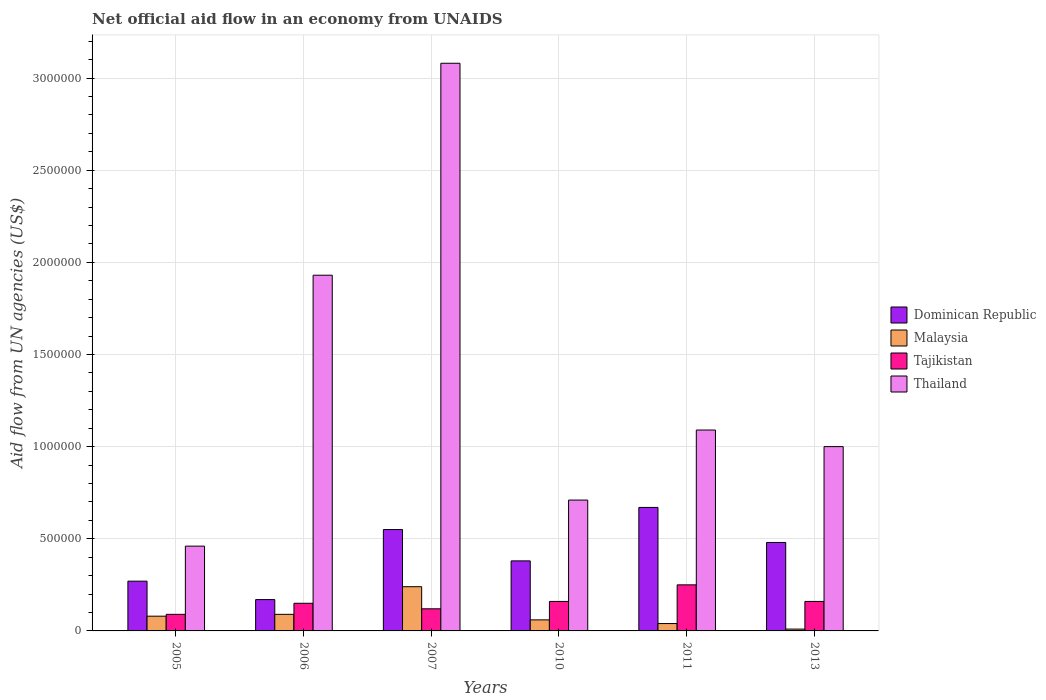How many different coloured bars are there?
Ensure brevity in your answer.  4. How many bars are there on the 1st tick from the left?
Make the answer very short. 4. How many bars are there on the 6th tick from the right?
Provide a succinct answer. 4. In how many cases, is the number of bars for a given year not equal to the number of legend labels?
Your answer should be compact. 0. What is the net official aid flow in Thailand in 2010?
Your answer should be compact. 7.10e+05. In which year was the net official aid flow in Tajikistan maximum?
Offer a terse response. 2011. In which year was the net official aid flow in Dominican Republic minimum?
Your answer should be compact. 2006. What is the total net official aid flow in Dominican Republic in the graph?
Your answer should be compact. 2.52e+06. What is the difference between the net official aid flow in Thailand in 2006 and that in 2010?
Make the answer very short. 1.22e+06. What is the difference between the net official aid flow in Thailand in 2005 and the net official aid flow in Malaysia in 2006?
Your answer should be compact. 3.70e+05. What is the average net official aid flow in Dominican Republic per year?
Ensure brevity in your answer.  4.20e+05. In the year 2011, what is the difference between the net official aid flow in Malaysia and net official aid flow in Dominican Republic?
Give a very brief answer. -6.30e+05. What is the ratio of the net official aid flow in Malaysia in 2006 to that in 2013?
Your answer should be very brief. 9. Is the net official aid flow in Thailand in 2007 less than that in 2010?
Your answer should be very brief. No. What is the difference between the highest and the second highest net official aid flow in Malaysia?
Keep it short and to the point. 1.50e+05. What is the difference between the highest and the lowest net official aid flow in Tajikistan?
Provide a succinct answer. 1.60e+05. What does the 2nd bar from the left in 2006 represents?
Your response must be concise. Malaysia. What does the 2nd bar from the right in 2005 represents?
Ensure brevity in your answer.  Tajikistan. Is it the case that in every year, the sum of the net official aid flow in Dominican Republic and net official aid flow in Thailand is greater than the net official aid flow in Malaysia?
Your answer should be very brief. Yes. How many years are there in the graph?
Make the answer very short. 6. Are the values on the major ticks of Y-axis written in scientific E-notation?
Offer a terse response. No. Does the graph contain grids?
Keep it short and to the point. Yes. What is the title of the graph?
Provide a succinct answer. Net official aid flow in an economy from UNAIDS. Does "Lao PDR" appear as one of the legend labels in the graph?
Keep it short and to the point. No. What is the label or title of the X-axis?
Give a very brief answer. Years. What is the label or title of the Y-axis?
Your answer should be compact. Aid flow from UN agencies (US$). What is the Aid flow from UN agencies (US$) in Malaysia in 2005?
Give a very brief answer. 8.00e+04. What is the Aid flow from UN agencies (US$) of Thailand in 2005?
Your answer should be very brief. 4.60e+05. What is the Aid flow from UN agencies (US$) of Dominican Republic in 2006?
Provide a succinct answer. 1.70e+05. What is the Aid flow from UN agencies (US$) of Malaysia in 2006?
Give a very brief answer. 9.00e+04. What is the Aid flow from UN agencies (US$) of Thailand in 2006?
Provide a short and direct response. 1.93e+06. What is the Aid flow from UN agencies (US$) of Dominican Republic in 2007?
Keep it short and to the point. 5.50e+05. What is the Aid flow from UN agencies (US$) of Tajikistan in 2007?
Ensure brevity in your answer.  1.20e+05. What is the Aid flow from UN agencies (US$) of Thailand in 2007?
Your answer should be compact. 3.08e+06. What is the Aid flow from UN agencies (US$) in Dominican Republic in 2010?
Your answer should be very brief. 3.80e+05. What is the Aid flow from UN agencies (US$) in Tajikistan in 2010?
Provide a succinct answer. 1.60e+05. What is the Aid flow from UN agencies (US$) of Thailand in 2010?
Offer a terse response. 7.10e+05. What is the Aid flow from UN agencies (US$) of Dominican Republic in 2011?
Your response must be concise. 6.70e+05. What is the Aid flow from UN agencies (US$) of Tajikistan in 2011?
Ensure brevity in your answer.  2.50e+05. What is the Aid flow from UN agencies (US$) in Thailand in 2011?
Provide a succinct answer. 1.09e+06. What is the Aid flow from UN agencies (US$) of Malaysia in 2013?
Ensure brevity in your answer.  10000. Across all years, what is the maximum Aid flow from UN agencies (US$) in Dominican Republic?
Ensure brevity in your answer.  6.70e+05. Across all years, what is the maximum Aid flow from UN agencies (US$) in Tajikistan?
Provide a succinct answer. 2.50e+05. Across all years, what is the maximum Aid flow from UN agencies (US$) of Thailand?
Your answer should be very brief. 3.08e+06. Across all years, what is the minimum Aid flow from UN agencies (US$) in Malaysia?
Offer a very short reply. 10000. Across all years, what is the minimum Aid flow from UN agencies (US$) in Tajikistan?
Keep it short and to the point. 9.00e+04. Across all years, what is the minimum Aid flow from UN agencies (US$) of Thailand?
Offer a terse response. 4.60e+05. What is the total Aid flow from UN agencies (US$) in Dominican Republic in the graph?
Provide a succinct answer. 2.52e+06. What is the total Aid flow from UN agencies (US$) in Malaysia in the graph?
Keep it short and to the point. 5.20e+05. What is the total Aid flow from UN agencies (US$) of Tajikistan in the graph?
Offer a terse response. 9.30e+05. What is the total Aid flow from UN agencies (US$) of Thailand in the graph?
Ensure brevity in your answer.  8.27e+06. What is the difference between the Aid flow from UN agencies (US$) in Malaysia in 2005 and that in 2006?
Make the answer very short. -10000. What is the difference between the Aid flow from UN agencies (US$) in Tajikistan in 2005 and that in 2006?
Offer a very short reply. -6.00e+04. What is the difference between the Aid flow from UN agencies (US$) in Thailand in 2005 and that in 2006?
Provide a short and direct response. -1.47e+06. What is the difference between the Aid flow from UN agencies (US$) of Dominican Republic in 2005 and that in 2007?
Provide a succinct answer. -2.80e+05. What is the difference between the Aid flow from UN agencies (US$) in Tajikistan in 2005 and that in 2007?
Provide a succinct answer. -3.00e+04. What is the difference between the Aid flow from UN agencies (US$) of Thailand in 2005 and that in 2007?
Offer a very short reply. -2.62e+06. What is the difference between the Aid flow from UN agencies (US$) in Dominican Republic in 2005 and that in 2011?
Offer a very short reply. -4.00e+05. What is the difference between the Aid flow from UN agencies (US$) in Malaysia in 2005 and that in 2011?
Offer a very short reply. 4.00e+04. What is the difference between the Aid flow from UN agencies (US$) of Tajikistan in 2005 and that in 2011?
Give a very brief answer. -1.60e+05. What is the difference between the Aid flow from UN agencies (US$) in Thailand in 2005 and that in 2011?
Offer a very short reply. -6.30e+05. What is the difference between the Aid flow from UN agencies (US$) in Malaysia in 2005 and that in 2013?
Your answer should be compact. 7.00e+04. What is the difference between the Aid flow from UN agencies (US$) of Tajikistan in 2005 and that in 2013?
Your answer should be very brief. -7.00e+04. What is the difference between the Aid flow from UN agencies (US$) in Thailand in 2005 and that in 2013?
Your answer should be compact. -5.40e+05. What is the difference between the Aid flow from UN agencies (US$) of Dominican Republic in 2006 and that in 2007?
Make the answer very short. -3.80e+05. What is the difference between the Aid flow from UN agencies (US$) of Thailand in 2006 and that in 2007?
Your answer should be very brief. -1.15e+06. What is the difference between the Aid flow from UN agencies (US$) of Dominican Republic in 2006 and that in 2010?
Your answer should be compact. -2.10e+05. What is the difference between the Aid flow from UN agencies (US$) in Tajikistan in 2006 and that in 2010?
Make the answer very short. -10000. What is the difference between the Aid flow from UN agencies (US$) in Thailand in 2006 and that in 2010?
Ensure brevity in your answer.  1.22e+06. What is the difference between the Aid flow from UN agencies (US$) of Dominican Republic in 2006 and that in 2011?
Keep it short and to the point. -5.00e+05. What is the difference between the Aid flow from UN agencies (US$) of Tajikistan in 2006 and that in 2011?
Your answer should be compact. -1.00e+05. What is the difference between the Aid flow from UN agencies (US$) in Thailand in 2006 and that in 2011?
Make the answer very short. 8.40e+05. What is the difference between the Aid flow from UN agencies (US$) in Dominican Republic in 2006 and that in 2013?
Offer a terse response. -3.10e+05. What is the difference between the Aid flow from UN agencies (US$) in Tajikistan in 2006 and that in 2013?
Your answer should be compact. -10000. What is the difference between the Aid flow from UN agencies (US$) in Thailand in 2006 and that in 2013?
Your answer should be compact. 9.30e+05. What is the difference between the Aid flow from UN agencies (US$) of Dominican Republic in 2007 and that in 2010?
Your response must be concise. 1.70e+05. What is the difference between the Aid flow from UN agencies (US$) in Malaysia in 2007 and that in 2010?
Ensure brevity in your answer.  1.80e+05. What is the difference between the Aid flow from UN agencies (US$) in Tajikistan in 2007 and that in 2010?
Your answer should be compact. -4.00e+04. What is the difference between the Aid flow from UN agencies (US$) of Thailand in 2007 and that in 2010?
Your answer should be compact. 2.37e+06. What is the difference between the Aid flow from UN agencies (US$) of Malaysia in 2007 and that in 2011?
Provide a succinct answer. 2.00e+05. What is the difference between the Aid flow from UN agencies (US$) in Thailand in 2007 and that in 2011?
Keep it short and to the point. 1.99e+06. What is the difference between the Aid flow from UN agencies (US$) in Dominican Republic in 2007 and that in 2013?
Your answer should be very brief. 7.00e+04. What is the difference between the Aid flow from UN agencies (US$) in Thailand in 2007 and that in 2013?
Provide a succinct answer. 2.08e+06. What is the difference between the Aid flow from UN agencies (US$) in Dominican Republic in 2010 and that in 2011?
Ensure brevity in your answer.  -2.90e+05. What is the difference between the Aid flow from UN agencies (US$) of Thailand in 2010 and that in 2011?
Give a very brief answer. -3.80e+05. What is the difference between the Aid flow from UN agencies (US$) in Tajikistan in 2010 and that in 2013?
Ensure brevity in your answer.  0. What is the difference between the Aid flow from UN agencies (US$) in Dominican Republic in 2011 and that in 2013?
Keep it short and to the point. 1.90e+05. What is the difference between the Aid flow from UN agencies (US$) in Malaysia in 2011 and that in 2013?
Provide a short and direct response. 3.00e+04. What is the difference between the Aid flow from UN agencies (US$) in Dominican Republic in 2005 and the Aid flow from UN agencies (US$) in Tajikistan in 2006?
Provide a succinct answer. 1.20e+05. What is the difference between the Aid flow from UN agencies (US$) in Dominican Republic in 2005 and the Aid flow from UN agencies (US$) in Thailand in 2006?
Provide a succinct answer. -1.66e+06. What is the difference between the Aid flow from UN agencies (US$) in Malaysia in 2005 and the Aid flow from UN agencies (US$) in Tajikistan in 2006?
Provide a succinct answer. -7.00e+04. What is the difference between the Aid flow from UN agencies (US$) of Malaysia in 2005 and the Aid flow from UN agencies (US$) of Thailand in 2006?
Ensure brevity in your answer.  -1.85e+06. What is the difference between the Aid flow from UN agencies (US$) of Tajikistan in 2005 and the Aid flow from UN agencies (US$) of Thailand in 2006?
Your response must be concise. -1.84e+06. What is the difference between the Aid flow from UN agencies (US$) in Dominican Republic in 2005 and the Aid flow from UN agencies (US$) in Thailand in 2007?
Provide a succinct answer. -2.81e+06. What is the difference between the Aid flow from UN agencies (US$) in Malaysia in 2005 and the Aid flow from UN agencies (US$) in Thailand in 2007?
Make the answer very short. -3.00e+06. What is the difference between the Aid flow from UN agencies (US$) of Tajikistan in 2005 and the Aid flow from UN agencies (US$) of Thailand in 2007?
Offer a very short reply. -2.99e+06. What is the difference between the Aid flow from UN agencies (US$) of Dominican Republic in 2005 and the Aid flow from UN agencies (US$) of Malaysia in 2010?
Make the answer very short. 2.10e+05. What is the difference between the Aid flow from UN agencies (US$) of Dominican Republic in 2005 and the Aid flow from UN agencies (US$) of Thailand in 2010?
Make the answer very short. -4.40e+05. What is the difference between the Aid flow from UN agencies (US$) of Malaysia in 2005 and the Aid flow from UN agencies (US$) of Tajikistan in 2010?
Provide a short and direct response. -8.00e+04. What is the difference between the Aid flow from UN agencies (US$) of Malaysia in 2005 and the Aid flow from UN agencies (US$) of Thailand in 2010?
Your answer should be very brief. -6.30e+05. What is the difference between the Aid flow from UN agencies (US$) in Tajikistan in 2005 and the Aid flow from UN agencies (US$) in Thailand in 2010?
Keep it short and to the point. -6.20e+05. What is the difference between the Aid flow from UN agencies (US$) of Dominican Republic in 2005 and the Aid flow from UN agencies (US$) of Malaysia in 2011?
Make the answer very short. 2.30e+05. What is the difference between the Aid flow from UN agencies (US$) in Dominican Republic in 2005 and the Aid flow from UN agencies (US$) in Tajikistan in 2011?
Offer a very short reply. 2.00e+04. What is the difference between the Aid flow from UN agencies (US$) of Dominican Republic in 2005 and the Aid flow from UN agencies (US$) of Thailand in 2011?
Keep it short and to the point. -8.20e+05. What is the difference between the Aid flow from UN agencies (US$) of Malaysia in 2005 and the Aid flow from UN agencies (US$) of Thailand in 2011?
Give a very brief answer. -1.01e+06. What is the difference between the Aid flow from UN agencies (US$) of Tajikistan in 2005 and the Aid flow from UN agencies (US$) of Thailand in 2011?
Your answer should be very brief. -1.00e+06. What is the difference between the Aid flow from UN agencies (US$) in Dominican Republic in 2005 and the Aid flow from UN agencies (US$) in Malaysia in 2013?
Ensure brevity in your answer.  2.60e+05. What is the difference between the Aid flow from UN agencies (US$) of Dominican Republic in 2005 and the Aid flow from UN agencies (US$) of Tajikistan in 2013?
Ensure brevity in your answer.  1.10e+05. What is the difference between the Aid flow from UN agencies (US$) of Dominican Republic in 2005 and the Aid flow from UN agencies (US$) of Thailand in 2013?
Your answer should be compact. -7.30e+05. What is the difference between the Aid flow from UN agencies (US$) of Malaysia in 2005 and the Aid flow from UN agencies (US$) of Thailand in 2013?
Provide a succinct answer. -9.20e+05. What is the difference between the Aid flow from UN agencies (US$) of Tajikistan in 2005 and the Aid flow from UN agencies (US$) of Thailand in 2013?
Ensure brevity in your answer.  -9.10e+05. What is the difference between the Aid flow from UN agencies (US$) of Dominican Republic in 2006 and the Aid flow from UN agencies (US$) of Tajikistan in 2007?
Provide a short and direct response. 5.00e+04. What is the difference between the Aid flow from UN agencies (US$) in Dominican Republic in 2006 and the Aid flow from UN agencies (US$) in Thailand in 2007?
Keep it short and to the point. -2.91e+06. What is the difference between the Aid flow from UN agencies (US$) of Malaysia in 2006 and the Aid flow from UN agencies (US$) of Tajikistan in 2007?
Your response must be concise. -3.00e+04. What is the difference between the Aid flow from UN agencies (US$) of Malaysia in 2006 and the Aid flow from UN agencies (US$) of Thailand in 2007?
Offer a terse response. -2.99e+06. What is the difference between the Aid flow from UN agencies (US$) in Tajikistan in 2006 and the Aid flow from UN agencies (US$) in Thailand in 2007?
Give a very brief answer. -2.93e+06. What is the difference between the Aid flow from UN agencies (US$) of Dominican Republic in 2006 and the Aid flow from UN agencies (US$) of Malaysia in 2010?
Offer a very short reply. 1.10e+05. What is the difference between the Aid flow from UN agencies (US$) in Dominican Republic in 2006 and the Aid flow from UN agencies (US$) in Tajikistan in 2010?
Offer a terse response. 10000. What is the difference between the Aid flow from UN agencies (US$) in Dominican Republic in 2006 and the Aid flow from UN agencies (US$) in Thailand in 2010?
Provide a short and direct response. -5.40e+05. What is the difference between the Aid flow from UN agencies (US$) in Malaysia in 2006 and the Aid flow from UN agencies (US$) in Thailand in 2010?
Ensure brevity in your answer.  -6.20e+05. What is the difference between the Aid flow from UN agencies (US$) of Tajikistan in 2006 and the Aid flow from UN agencies (US$) of Thailand in 2010?
Offer a very short reply. -5.60e+05. What is the difference between the Aid flow from UN agencies (US$) of Dominican Republic in 2006 and the Aid flow from UN agencies (US$) of Malaysia in 2011?
Offer a very short reply. 1.30e+05. What is the difference between the Aid flow from UN agencies (US$) in Dominican Republic in 2006 and the Aid flow from UN agencies (US$) in Tajikistan in 2011?
Make the answer very short. -8.00e+04. What is the difference between the Aid flow from UN agencies (US$) of Dominican Republic in 2006 and the Aid flow from UN agencies (US$) of Thailand in 2011?
Make the answer very short. -9.20e+05. What is the difference between the Aid flow from UN agencies (US$) in Malaysia in 2006 and the Aid flow from UN agencies (US$) in Tajikistan in 2011?
Give a very brief answer. -1.60e+05. What is the difference between the Aid flow from UN agencies (US$) of Malaysia in 2006 and the Aid flow from UN agencies (US$) of Thailand in 2011?
Make the answer very short. -1.00e+06. What is the difference between the Aid flow from UN agencies (US$) of Tajikistan in 2006 and the Aid flow from UN agencies (US$) of Thailand in 2011?
Your answer should be very brief. -9.40e+05. What is the difference between the Aid flow from UN agencies (US$) in Dominican Republic in 2006 and the Aid flow from UN agencies (US$) in Tajikistan in 2013?
Offer a terse response. 10000. What is the difference between the Aid flow from UN agencies (US$) in Dominican Republic in 2006 and the Aid flow from UN agencies (US$) in Thailand in 2013?
Give a very brief answer. -8.30e+05. What is the difference between the Aid flow from UN agencies (US$) in Malaysia in 2006 and the Aid flow from UN agencies (US$) in Tajikistan in 2013?
Your answer should be very brief. -7.00e+04. What is the difference between the Aid flow from UN agencies (US$) of Malaysia in 2006 and the Aid flow from UN agencies (US$) of Thailand in 2013?
Provide a succinct answer. -9.10e+05. What is the difference between the Aid flow from UN agencies (US$) of Tajikistan in 2006 and the Aid flow from UN agencies (US$) of Thailand in 2013?
Give a very brief answer. -8.50e+05. What is the difference between the Aid flow from UN agencies (US$) in Dominican Republic in 2007 and the Aid flow from UN agencies (US$) in Tajikistan in 2010?
Give a very brief answer. 3.90e+05. What is the difference between the Aid flow from UN agencies (US$) of Malaysia in 2007 and the Aid flow from UN agencies (US$) of Tajikistan in 2010?
Provide a short and direct response. 8.00e+04. What is the difference between the Aid flow from UN agencies (US$) of Malaysia in 2007 and the Aid flow from UN agencies (US$) of Thailand in 2010?
Offer a very short reply. -4.70e+05. What is the difference between the Aid flow from UN agencies (US$) of Tajikistan in 2007 and the Aid flow from UN agencies (US$) of Thailand in 2010?
Provide a succinct answer. -5.90e+05. What is the difference between the Aid flow from UN agencies (US$) in Dominican Republic in 2007 and the Aid flow from UN agencies (US$) in Malaysia in 2011?
Your answer should be very brief. 5.10e+05. What is the difference between the Aid flow from UN agencies (US$) in Dominican Republic in 2007 and the Aid flow from UN agencies (US$) in Thailand in 2011?
Make the answer very short. -5.40e+05. What is the difference between the Aid flow from UN agencies (US$) of Malaysia in 2007 and the Aid flow from UN agencies (US$) of Thailand in 2011?
Offer a very short reply. -8.50e+05. What is the difference between the Aid flow from UN agencies (US$) of Tajikistan in 2007 and the Aid flow from UN agencies (US$) of Thailand in 2011?
Ensure brevity in your answer.  -9.70e+05. What is the difference between the Aid flow from UN agencies (US$) of Dominican Republic in 2007 and the Aid flow from UN agencies (US$) of Malaysia in 2013?
Keep it short and to the point. 5.40e+05. What is the difference between the Aid flow from UN agencies (US$) in Dominican Republic in 2007 and the Aid flow from UN agencies (US$) in Tajikistan in 2013?
Make the answer very short. 3.90e+05. What is the difference between the Aid flow from UN agencies (US$) in Dominican Republic in 2007 and the Aid flow from UN agencies (US$) in Thailand in 2013?
Provide a short and direct response. -4.50e+05. What is the difference between the Aid flow from UN agencies (US$) in Malaysia in 2007 and the Aid flow from UN agencies (US$) in Tajikistan in 2013?
Offer a very short reply. 8.00e+04. What is the difference between the Aid flow from UN agencies (US$) of Malaysia in 2007 and the Aid flow from UN agencies (US$) of Thailand in 2013?
Provide a short and direct response. -7.60e+05. What is the difference between the Aid flow from UN agencies (US$) of Tajikistan in 2007 and the Aid flow from UN agencies (US$) of Thailand in 2013?
Keep it short and to the point. -8.80e+05. What is the difference between the Aid flow from UN agencies (US$) of Dominican Republic in 2010 and the Aid flow from UN agencies (US$) of Thailand in 2011?
Give a very brief answer. -7.10e+05. What is the difference between the Aid flow from UN agencies (US$) in Malaysia in 2010 and the Aid flow from UN agencies (US$) in Thailand in 2011?
Provide a succinct answer. -1.03e+06. What is the difference between the Aid flow from UN agencies (US$) in Tajikistan in 2010 and the Aid flow from UN agencies (US$) in Thailand in 2011?
Offer a terse response. -9.30e+05. What is the difference between the Aid flow from UN agencies (US$) in Dominican Republic in 2010 and the Aid flow from UN agencies (US$) in Tajikistan in 2013?
Keep it short and to the point. 2.20e+05. What is the difference between the Aid flow from UN agencies (US$) of Dominican Republic in 2010 and the Aid flow from UN agencies (US$) of Thailand in 2013?
Provide a succinct answer. -6.20e+05. What is the difference between the Aid flow from UN agencies (US$) of Malaysia in 2010 and the Aid flow from UN agencies (US$) of Thailand in 2013?
Ensure brevity in your answer.  -9.40e+05. What is the difference between the Aid flow from UN agencies (US$) in Tajikistan in 2010 and the Aid flow from UN agencies (US$) in Thailand in 2013?
Make the answer very short. -8.40e+05. What is the difference between the Aid flow from UN agencies (US$) of Dominican Republic in 2011 and the Aid flow from UN agencies (US$) of Tajikistan in 2013?
Your answer should be compact. 5.10e+05. What is the difference between the Aid flow from UN agencies (US$) in Dominican Republic in 2011 and the Aid flow from UN agencies (US$) in Thailand in 2013?
Offer a terse response. -3.30e+05. What is the difference between the Aid flow from UN agencies (US$) of Malaysia in 2011 and the Aid flow from UN agencies (US$) of Thailand in 2013?
Give a very brief answer. -9.60e+05. What is the difference between the Aid flow from UN agencies (US$) in Tajikistan in 2011 and the Aid flow from UN agencies (US$) in Thailand in 2013?
Keep it short and to the point. -7.50e+05. What is the average Aid flow from UN agencies (US$) of Malaysia per year?
Keep it short and to the point. 8.67e+04. What is the average Aid flow from UN agencies (US$) of Tajikistan per year?
Give a very brief answer. 1.55e+05. What is the average Aid flow from UN agencies (US$) of Thailand per year?
Make the answer very short. 1.38e+06. In the year 2005, what is the difference between the Aid flow from UN agencies (US$) of Dominican Republic and Aid flow from UN agencies (US$) of Thailand?
Offer a very short reply. -1.90e+05. In the year 2005, what is the difference between the Aid flow from UN agencies (US$) of Malaysia and Aid flow from UN agencies (US$) of Tajikistan?
Provide a succinct answer. -10000. In the year 2005, what is the difference between the Aid flow from UN agencies (US$) of Malaysia and Aid flow from UN agencies (US$) of Thailand?
Make the answer very short. -3.80e+05. In the year 2005, what is the difference between the Aid flow from UN agencies (US$) of Tajikistan and Aid flow from UN agencies (US$) of Thailand?
Give a very brief answer. -3.70e+05. In the year 2006, what is the difference between the Aid flow from UN agencies (US$) of Dominican Republic and Aid flow from UN agencies (US$) of Thailand?
Give a very brief answer. -1.76e+06. In the year 2006, what is the difference between the Aid flow from UN agencies (US$) in Malaysia and Aid flow from UN agencies (US$) in Tajikistan?
Offer a very short reply. -6.00e+04. In the year 2006, what is the difference between the Aid flow from UN agencies (US$) of Malaysia and Aid flow from UN agencies (US$) of Thailand?
Make the answer very short. -1.84e+06. In the year 2006, what is the difference between the Aid flow from UN agencies (US$) of Tajikistan and Aid flow from UN agencies (US$) of Thailand?
Ensure brevity in your answer.  -1.78e+06. In the year 2007, what is the difference between the Aid flow from UN agencies (US$) of Dominican Republic and Aid flow from UN agencies (US$) of Malaysia?
Offer a terse response. 3.10e+05. In the year 2007, what is the difference between the Aid flow from UN agencies (US$) in Dominican Republic and Aid flow from UN agencies (US$) in Tajikistan?
Give a very brief answer. 4.30e+05. In the year 2007, what is the difference between the Aid flow from UN agencies (US$) in Dominican Republic and Aid flow from UN agencies (US$) in Thailand?
Your answer should be compact. -2.53e+06. In the year 2007, what is the difference between the Aid flow from UN agencies (US$) in Malaysia and Aid flow from UN agencies (US$) in Tajikistan?
Your answer should be compact. 1.20e+05. In the year 2007, what is the difference between the Aid flow from UN agencies (US$) in Malaysia and Aid flow from UN agencies (US$) in Thailand?
Give a very brief answer. -2.84e+06. In the year 2007, what is the difference between the Aid flow from UN agencies (US$) of Tajikistan and Aid flow from UN agencies (US$) of Thailand?
Your response must be concise. -2.96e+06. In the year 2010, what is the difference between the Aid flow from UN agencies (US$) in Dominican Republic and Aid flow from UN agencies (US$) in Thailand?
Make the answer very short. -3.30e+05. In the year 2010, what is the difference between the Aid flow from UN agencies (US$) of Malaysia and Aid flow from UN agencies (US$) of Thailand?
Your answer should be compact. -6.50e+05. In the year 2010, what is the difference between the Aid flow from UN agencies (US$) of Tajikistan and Aid flow from UN agencies (US$) of Thailand?
Your answer should be compact. -5.50e+05. In the year 2011, what is the difference between the Aid flow from UN agencies (US$) of Dominican Republic and Aid flow from UN agencies (US$) of Malaysia?
Your response must be concise. 6.30e+05. In the year 2011, what is the difference between the Aid flow from UN agencies (US$) of Dominican Republic and Aid flow from UN agencies (US$) of Tajikistan?
Ensure brevity in your answer.  4.20e+05. In the year 2011, what is the difference between the Aid flow from UN agencies (US$) of Dominican Republic and Aid flow from UN agencies (US$) of Thailand?
Provide a short and direct response. -4.20e+05. In the year 2011, what is the difference between the Aid flow from UN agencies (US$) in Malaysia and Aid flow from UN agencies (US$) in Tajikistan?
Offer a terse response. -2.10e+05. In the year 2011, what is the difference between the Aid flow from UN agencies (US$) of Malaysia and Aid flow from UN agencies (US$) of Thailand?
Offer a very short reply. -1.05e+06. In the year 2011, what is the difference between the Aid flow from UN agencies (US$) of Tajikistan and Aid flow from UN agencies (US$) of Thailand?
Keep it short and to the point. -8.40e+05. In the year 2013, what is the difference between the Aid flow from UN agencies (US$) in Dominican Republic and Aid flow from UN agencies (US$) in Malaysia?
Offer a very short reply. 4.70e+05. In the year 2013, what is the difference between the Aid flow from UN agencies (US$) of Dominican Republic and Aid flow from UN agencies (US$) of Thailand?
Provide a succinct answer. -5.20e+05. In the year 2013, what is the difference between the Aid flow from UN agencies (US$) of Malaysia and Aid flow from UN agencies (US$) of Thailand?
Offer a very short reply. -9.90e+05. In the year 2013, what is the difference between the Aid flow from UN agencies (US$) in Tajikistan and Aid flow from UN agencies (US$) in Thailand?
Offer a very short reply. -8.40e+05. What is the ratio of the Aid flow from UN agencies (US$) of Dominican Republic in 2005 to that in 2006?
Ensure brevity in your answer.  1.59. What is the ratio of the Aid flow from UN agencies (US$) of Malaysia in 2005 to that in 2006?
Your answer should be very brief. 0.89. What is the ratio of the Aid flow from UN agencies (US$) in Tajikistan in 2005 to that in 2006?
Provide a short and direct response. 0.6. What is the ratio of the Aid flow from UN agencies (US$) in Thailand in 2005 to that in 2006?
Your answer should be compact. 0.24. What is the ratio of the Aid flow from UN agencies (US$) in Dominican Republic in 2005 to that in 2007?
Your response must be concise. 0.49. What is the ratio of the Aid flow from UN agencies (US$) of Tajikistan in 2005 to that in 2007?
Ensure brevity in your answer.  0.75. What is the ratio of the Aid flow from UN agencies (US$) of Thailand in 2005 to that in 2007?
Your response must be concise. 0.15. What is the ratio of the Aid flow from UN agencies (US$) of Dominican Republic in 2005 to that in 2010?
Provide a succinct answer. 0.71. What is the ratio of the Aid flow from UN agencies (US$) in Tajikistan in 2005 to that in 2010?
Offer a terse response. 0.56. What is the ratio of the Aid flow from UN agencies (US$) in Thailand in 2005 to that in 2010?
Offer a very short reply. 0.65. What is the ratio of the Aid flow from UN agencies (US$) in Dominican Republic in 2005 to that in 2011?
Make the answer very short. 0.4. What is the ratio of the Aid flow from UN agencies (US$) of Tajikistan in 2005 to that in 2011?
Ensure brevity in your answer.  0.36. What is the ratio of the Aid flow from UN agencies (US$) of Thailand in 2005 to that in 2011?
Your answer should be very brief. 0.42. What is the ratio of the Aid flow from UN agencies (US$) of Dominican Republic in 2005 to that in 2013?
Make the answer very short. 0.56. What is the ratio of the Aid flow from UN agencies (US$) of Tajikistan in 2005 to that in 2013?
Keep it short and to the point. 0.56. What is the ratio of the Aid flow from UN agencies (US$) of Thailand in 2005 to that in 2013?
Make the answer very short. 0.46. What is the ratio of the Aid flow from UN agencies (US$) of Dominican Republic in 2006 to that in 2007?
Give a very brief answer. 0.31. What is the ratio of the Aid flow from UN agencies (US$) in Thailand in 2006 to that in 2007?
Keep it short and to the point. 0.63. What is the ratio of the Aid flow from UN agencies (US$) of Dominican Republic in 2006 to that in 2010?
Offer a very short reply. 0.45. What is the ratio of the Aid flow from UN agencies (US$) in Malaysia in 2006 to that in 2010?
Ensure brevity in your answer.  1.5. What is the ratio of the Aid flow from UN agencies (US$) of Thailand in 2006 to that in 2010?
Ensure brevity in your answer.  2.72. What is the ratio of the Aid flow from UN agencies (US$) in Dominican Republic in 2006 to that in 2011?
Provide a short and direct response. 0.25. What is the ratio of the Aid flow from UN agencies (US$) of Malaysia in 2006 to that in 2011?
Your answer should be compact. 2.25. What is the ratio of the Aid flow from UN agencies (US$) in Tajikistan in 2006 to that in 2011?
Keep it short and to the point. 0.6. What is the ratio of the Aid flow from UN agencies (US$) in Thailand in 2006 to that in 2011?
Ensure brevity in your answer.  1.77. What is the ratio of the Aid flow from UN agencies (US$) in Dominican Republic in 2006 to that in 2013?
Your answer should be compact. 0.35. What is the ratio of the Aid flow from UN agencies (US$) in Tajikistan in 2006 to that in 2013?
Keep it short and to the point. 0.94. What is the ratio of the Aid flow from UN agencies (US$) in Thailand in 2006 to that in 2013?
Your response must be concise. 1.93. What is the ratio of the Aid flow from UN agencies (US$) in Dominican Republic in 2007 to that in 2010?
Provide a succinct answer. 1.45. What is the ratio of the Aid flow from UN agencies (US$) in Malaysia in 2007 to that in 2010?
Ensure brevity in your answer.  4. What is the ratio of the Aid flow from UN agencies (US$) of Tajikistan in 2007 to that in 2010?
Your response must be concise. 0.75. What is the ratio of the Aid flow from UN agencies (US$) in Thailand in 2007 to that in 2010?
Provide a short and direct response. 4.34. What is the ratio of the Aid flow from UN agencies (US$) in Dominican Republic in 2007 to that in 2011?
Give a very brief answer. 0.82. What is the ratio of the Aid flow from UN agencies (US$) of Tajikistan in 2007 to that in 2011?
Give a very brief answer. 0.48. What is the ratio of the Aid flow from UN agencies (US$) in Thailand in 2007 to that in 2011?
Provide a succinct answer. 2.83. What is the ratio of the Aid flow from UN agencies (US$) of Dominican Republic in 2007 to that in 2013?
Ensure brevity in your answer.  1.15. What is the ratio of the Aid flow from UN agencies (US$) in Thailand in 2007 to that in 2013?
Ensure brevity in your answer.  3.08. What is the ratio of the Aid flow from UN agencies (US$) of Dominican Republic in 2010 to that in 2011?
Offer a terse response. 0.57. What is the ratio of the Aid flow from UN agencies (US$) of Tajikistan in 2010 to that in 2011?
Ensure brevity in your answer.  0.64. What is the ratio of the Aid flow from UN agencies (US$) of Thailand in 2010 to that in 2011?
Your answer should be very brief. 0.65. What is the ratio of the Aid flow from UN agencies (US$) of Dominican Republic in 2010 to that in 2013?
Give a very brief answer. 0.79. What is the ratio of the Aid flow from UN agencies (US$) in Malaysia in 2010 to that in 2013?
Keep it short and to the point. 6. What is the ratio of the Aid flow from UN agencies (US$) in Thailand in 2010 to that in 2013?
Give a very brief answer. 0.71. What is the ratio of the Aid flow from UN agencies (US$) in Dominican Republic in 2011 to that in 2013?
Your answer should be very brief. 1.4. What is the ratio of the Aid flow from UN agencies (US$) of Tajikistan in 2011 to that in 2013?
Provide a short and direct response. 1.56. What is the ratio of the Aid flow from UN agencies (US$) in Thailand in 2011 to that in 2013?
Your answer should be compact. 1.09. What is the difference between the highest and the second highest Aid flow from UN agencies (US$) in Dominican Republic?
Offer a very short reply. 1.20e+05. What is the difference between the highest and the second highest Aid flow from UN agencies (US$) in Malaysia?
Provide a short and direct response. 1.50e+05. What is the difference between the highest and the second highest Aid flow from UN agencies (US$) of Thailand?
Ensure brevity in your answer.  1.15e+06. What is the difference between the highest and the lowest Aid flow from UN agencies (US$) in Thailand?
Provide a succinct answer. 2.62e+06. 